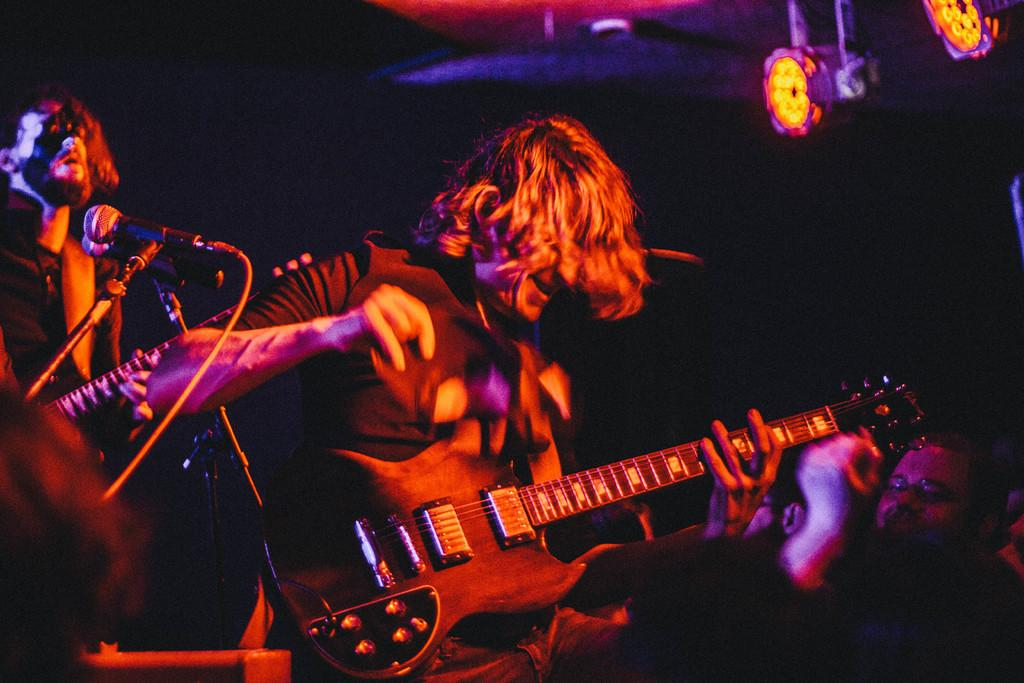What are the people in the image doing? The people in the image are playing guitars. What objects are present that might be used for amplifying sound? There are microphones in the image. What type of lighting can be seen in the background? There are focusing lights in the background. How would you describe the overall lighting in the image? The background is dark. What type of clam is being used as a percussion instrument in the image? There is no clam present in the image, and no percussion instruments are mentioned. 